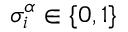<formula> <loc_0><loc_0><loc_500><loc_500>\sigma _ { i } ^ { \alpha } \in \{ 0 , 1 \}</formula> 